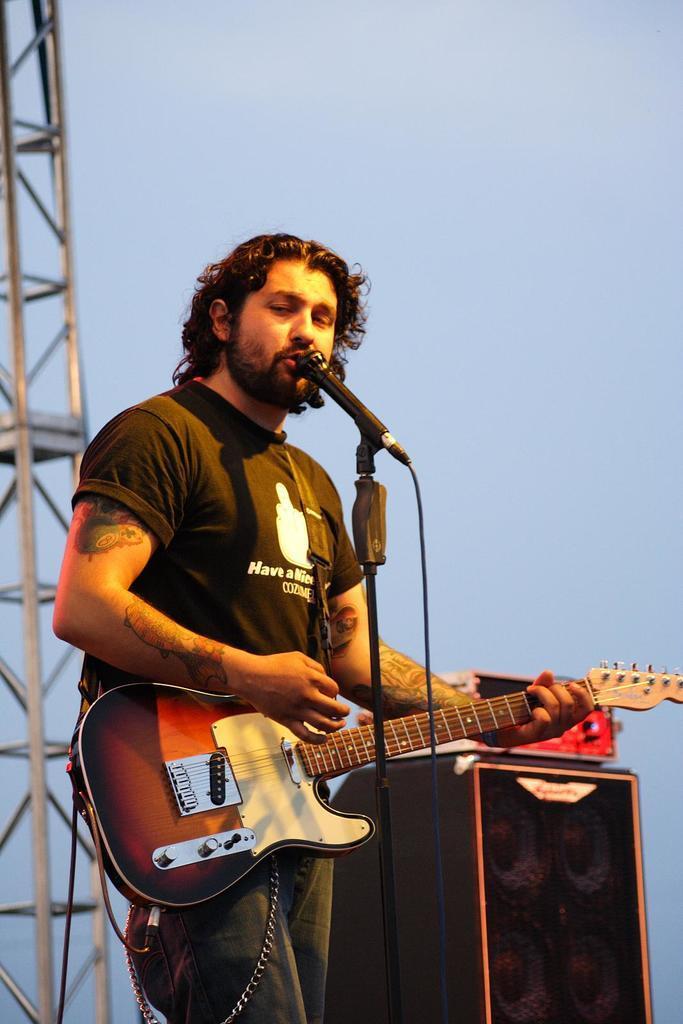Could you give a brief overview of what you see in this image? In this image, in the foreground i can see a person playing guitar and i can see there is a mike and background is sky. 